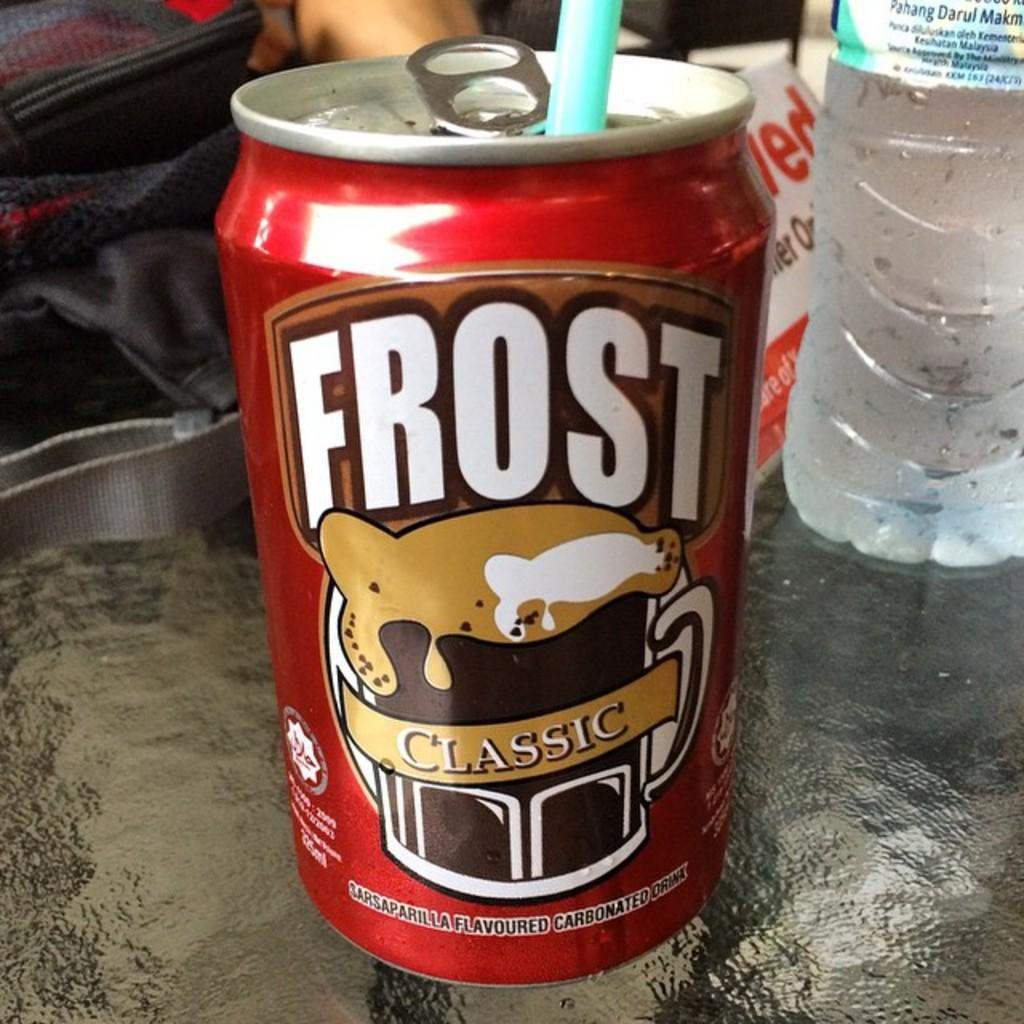<image>
Give a short and clear explanation of the subsequent image. A straw is in the can of Frost Classic. 